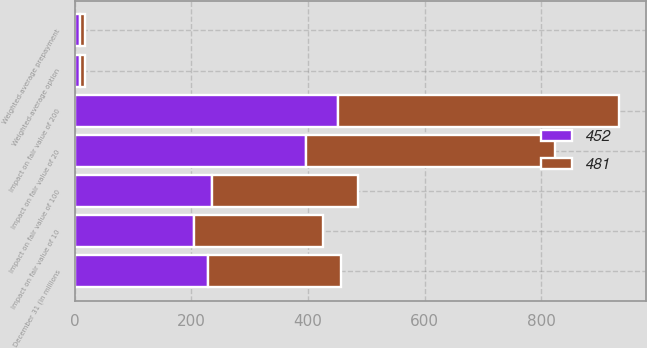Convert chart to OTSL. <chart><loc_0><loc_0><loc_500><loc_500><stacked_bar_chart><ecel><fcel>December 31 (in millions<fcel>Weighted-average prepayment<fcel>Impact on fair value of 10<fcel>Impact on fair value of 20<fcel>Weighted-average option<fcel>Impact on fair value of 100<fcel>Impact on fair value of 200<nl><fcel>452<fcel>228<fcel>8.78<fcel>205<fcel>397<fcel>8.7<fcel>235<fcel>452<nl><fcel>481<fcel>228<fcel>9.35<fcel>221<fcel>427<fcel>9.04<fcel>250<fcel>481<nl></chart> 